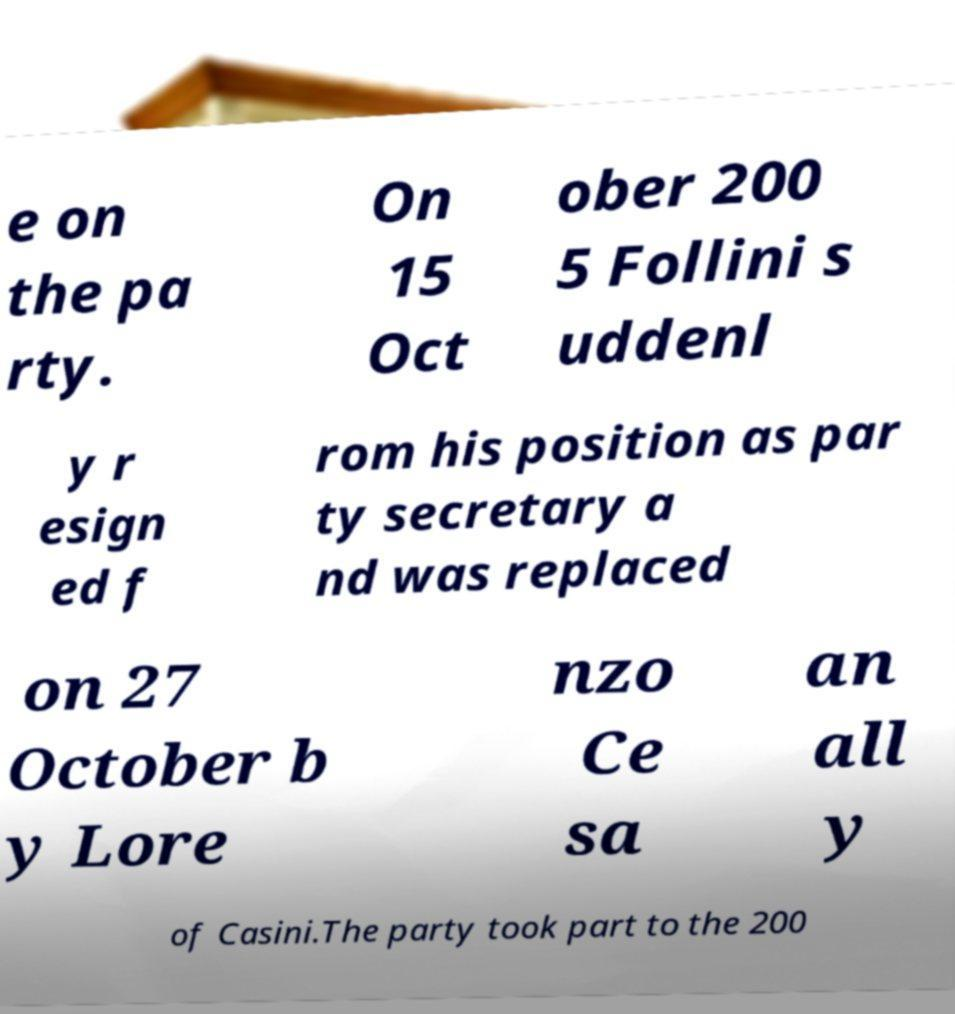Please identify and transcribe the text found in this image. e on the pa rty. On 15 Oct ober 200 5 Follini s uddenl y r esign ed f rom his position as par ty secretary a nd was replaced on 27 October b y Lore nzo Ce sa an all y of Casini.The party took part to the 200 